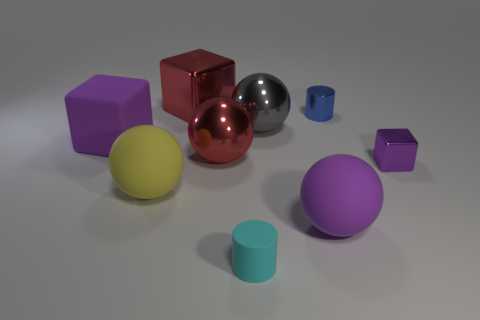There is a thing that is on the right side of the big gray thing and behind the large purple cube; what is its shape?
Provide a succinct answer. Cylinder. Are there more large rubber objects behind the purple sphere than large yellow things to the left of the big yellow matte sphere?
Provide a succinct answer. Yes. What number of other things are there of the same size as the blue metallic cylinder?
Keep it short and to the point. 2. The rubber thing that is the same color as the large rubber block is what size?
Ensure brevity in your answer.  Large. The big sphere on the left side of the large cube behind the small blue metal cylinder is made of what material?
Your answer should be very brief. Rubber. Are there any matte balls to the right of the yellow ball?
Give a very brief answer. Yes. Are there more big shiny spheres that are behind the cyan cylinder than big red blocks?
Ensure brevity in your answer.  Yes. Is there a large matte block of the same color as the small matte cylinder?
Provide a succinct answer. No. What is the color of the metal cube that is the same size as the purple sphere?
Offer a terse response. Red. Is there a big gray sphere that is in front of the metallic cube behind the small block?
Give a very brief answer. Yes. 